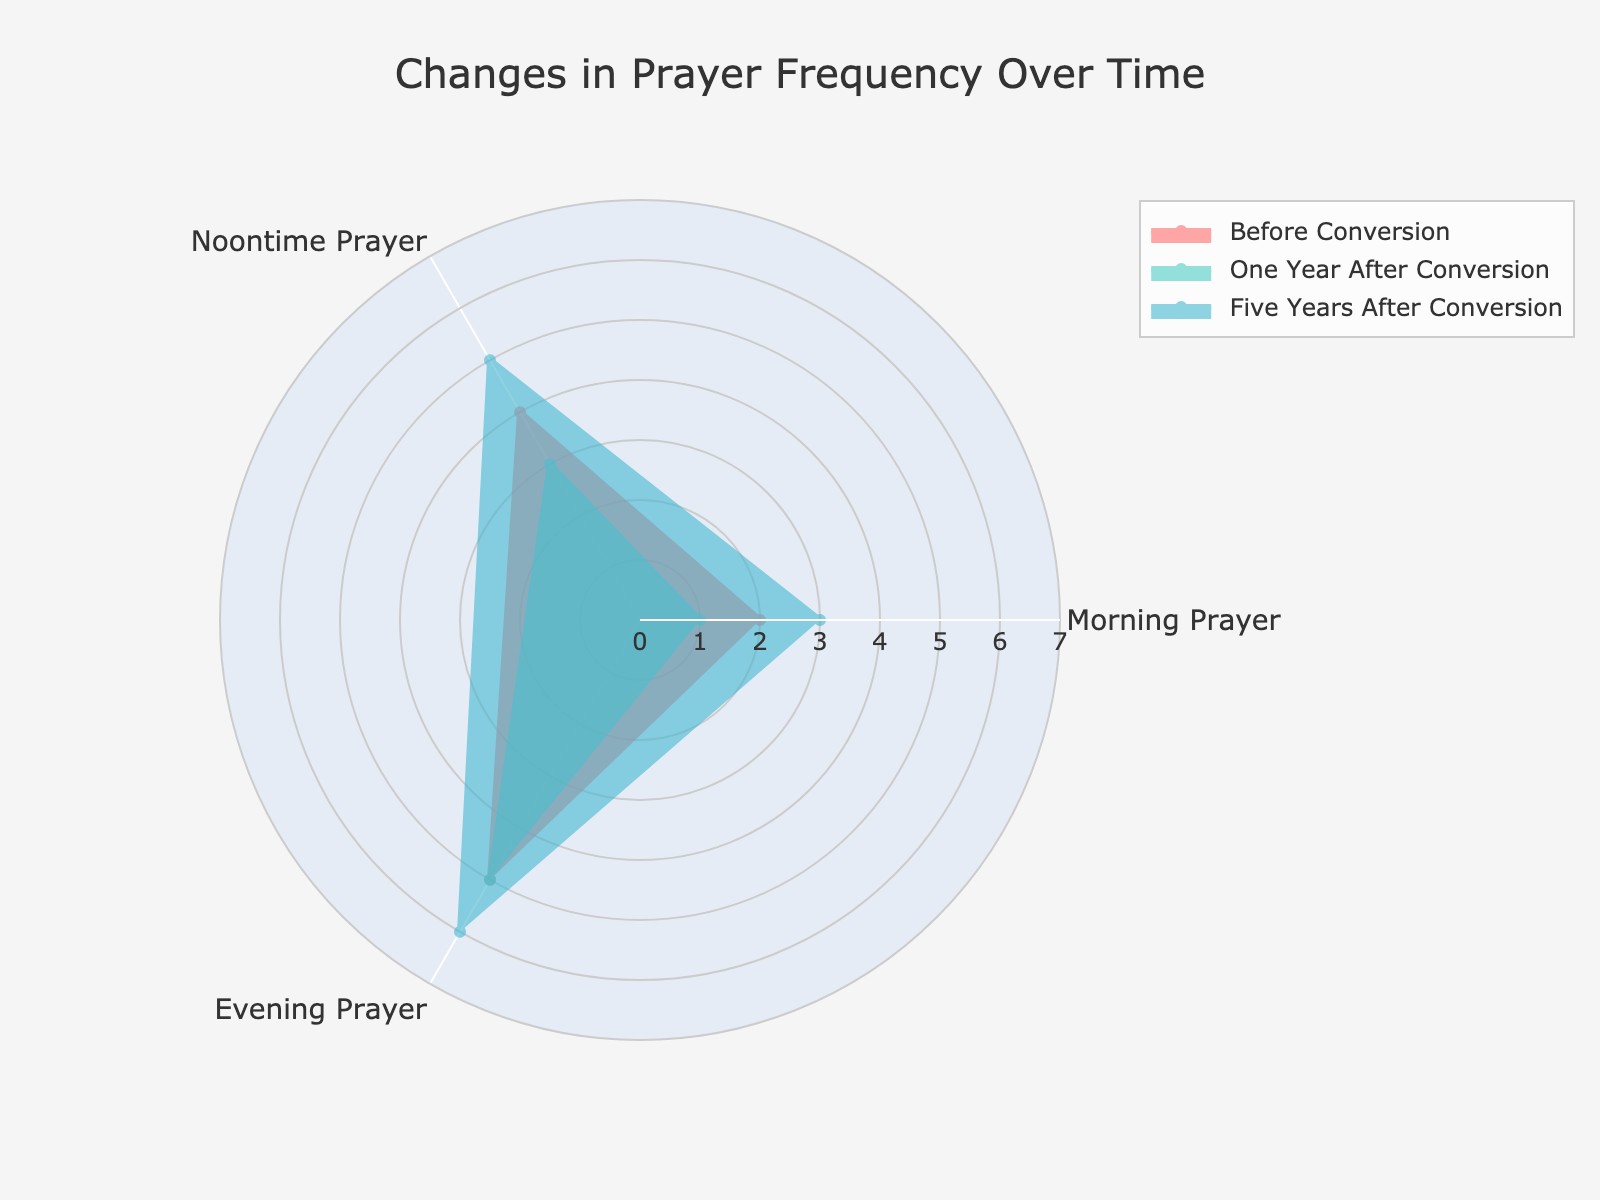What is the title of the radar chart? The title of the radar chart is located at the top of the figure.
Answer: Changes in Prayer Frequency Over Time What color represents the period "Five Years After Conversion"? The color for each period can be identified by looking at the color of the lines and fills in the chart legend. According to the given order in the code, 'Five Years After Conversion' is represented by the third color, which is light blue.
Answer: Light blue Which prayer activity shows the highest frequency in the period "One Year After Conversion"? To answer this, we refer to the radar chart and look at the 'One Year After Conversion' (green) data for the peak value. The highest point for this period is for "Evening Prayer."
Answer: Evening Prayer What is the overall trend in frequency for "Noontime Prayer" over the three periods? To assess the trend, observe the data points for "Noontime Prayer" across all periods. Initially, it starts low, then increases significantly, and continues to rise.
Answer: Increasing Which activity had the most significant increase in frequency from "Before Conversion" to "Five Years After Conversion"? To determine this, we calculate the difference in frequency for each activity between the "Before Conversion" and "Five Years After Conversion" periods. The highest difference is observed for "Noontime Prayer" (5 - 1 = 4).
Answer: Noontime Prayer How does the frequency of "Weekly Study Group" compare between "Before Conversion" and "One Year After Conversion"? The frequency of "Weekly Study Group" before conversion is 0 and then changes to 2 one year after. This shows an increase of 2 units.
Answer: Increased by 2 Which period, on average, shows the highest frequency for all activities combined? Calculate the average frequency for each period by summing the values and dividing by the number of activities. The averages are (2+1+3+0)/4 = 1.5, (4+3+5+2)/4 = 3.5, and (5+5+6+3)/4 = 4.75 respectively.
Answer: Five Years After Conversion 